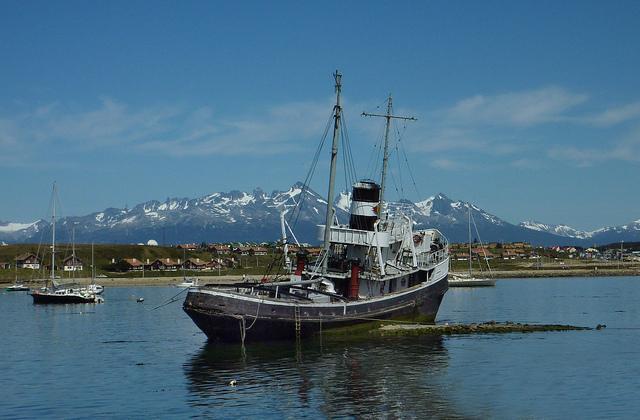How many boats are there?
Give a very brief answer. 2. 